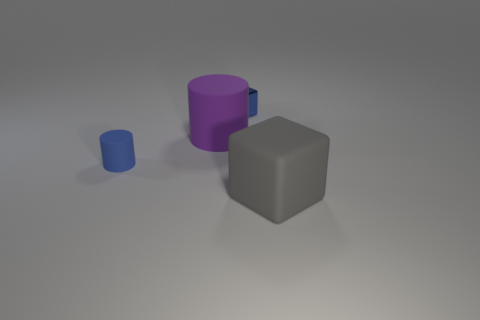There is a tiny thing to the left of the small blue shiny cube; does it have the same color as the small shiny cube?
Give a very brief answer. Yes. What number of gray rubber cubes are in front of the large rubber thing that is in front of the blue thing in front of the tiny block?
Your answer should be very brief. 0. There is a big purple matte cylinder; what number of small metal cubes are behind it?
Provide a succinct answer. 1. What is the color of the tiny matte thing that is the same shape as the large purple object?
Give a very brief answer. Blue. There is a object that is both to the right of the tiny blue rubber cylinder and in front of the purple rubber thing; what material is it?
Give a very brief answer. Rubber. There is a object on the right side of the blue cube; is its size the same as the blue block?
Ensure brevity in your answer.  No. What is the big gray cube made of?
Offer a very short reply. Rubber. There is a small object behind the small blue rubber cylinder; what is its color?
Your response must be concise. Blue. What number of large things are green rubber blocks or matte things?
Ensure brevity in your answer.  2. Is the color of the thing that is right of the blue metallic block the same as the tiny object that is right of the purple rubber object?
Offer a very short reply. No. 